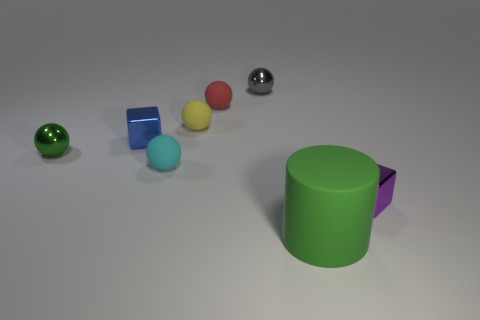Add 1 green matte cylinders. How many objects exist? 9 Subtract all balls. How many objects are left? 3 Subtract 1 cylinders. How many cylinders are left? 0 Subtract all blue blocks. Subtract all purple cylinders. How many blocks are left? 1 Subtract all brown balls. How many cyan cylinders are left? 0 Subtract all purple metal blocks. Subtract all tiny matte things. How many objects are left? 4 Add 5 small green metallic balls. How many small green metallic balls are left? 6 Add 4 small gray things. How many small gray things exist? 5 Subtract all red spheres. How many spheres are left? 4 Subtract all gray spheres. How many spheres are left? 4 